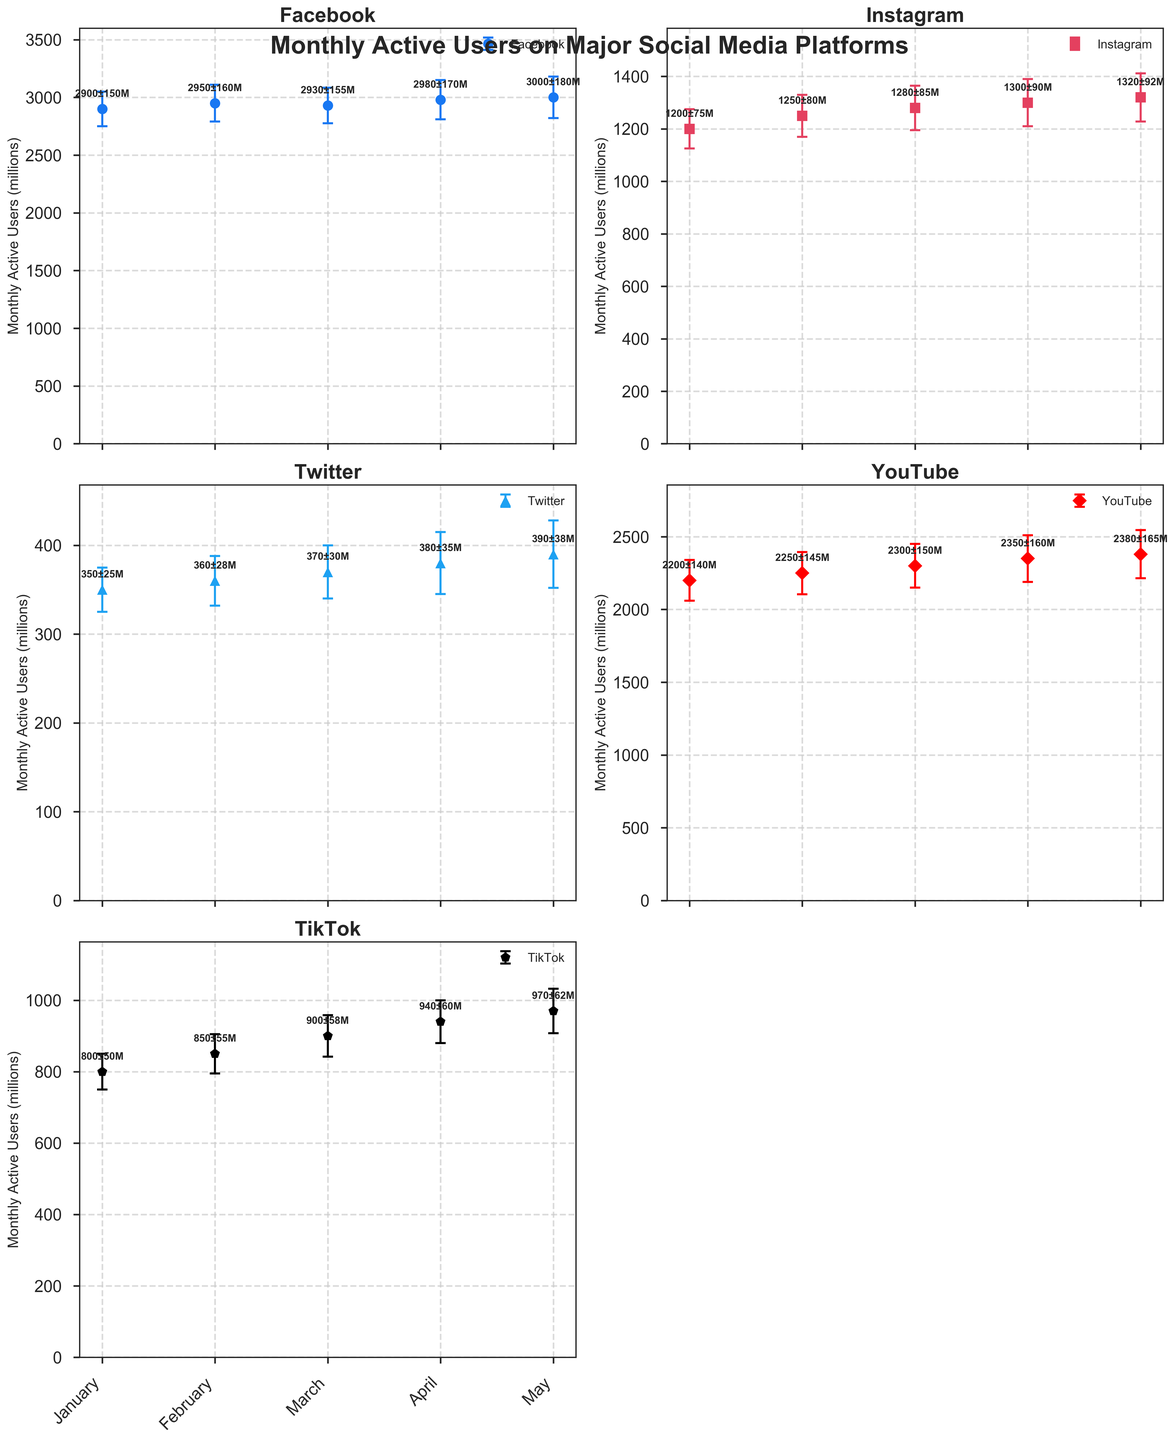What is the title of the figure? The title is displayed at the top of the figure and reads, "Monthly Active Users on Major Social Media Platforms".
Answer: Monthly Active Users on Major Social Media Platforms How many platforms are displayed in the figure? The figure shows five major social media platforms.
Answer: 5 Which platform has the smallest error margin in January? By examining the error bars, Twitter has the smallest error margin of 25 million in January.
Answer: Twitter What is the average Monthly Active Users (MAU) for Instagram across the months shown? The MAUs for Instagram are January: 1200, February: 1250, March: 1280, April: 1300, and May: 1320. Their average is (1200 + 1250 + 1280 + 1300 + 1320) / 5 = 6350 / 5 = 1270.
Answer: 1270 Which platform shows the largest increase in Monthly Active Users from January to May? The Monthly Active Users (MAU) increase for each platform is computed from January to May data. TikTok shows an increase from 800 to 970, an increase of 170 million, the largest among all platforms.
Answer: TikTok Which month shows the highest Monthly Active Users for Facebook? The highest MAU for Facebook is in May at 3000 million users.
Answer: May Compare the Monthly Active Users for YouTube in February and March. Which month has a higher MAU and by how much? YouTube's MAU for February is 2250 and for March is 2300. March has a higher MAU with a difference of 2300 - 2250 = 50 million.
Answer: March, by 50 million What is the range of error margins for TikTok across all months? TikTok's error margins across the months are January: 50, February: 55, March: 58, April: 60, and May: 62. The range is from 50 to 62 million.
Answer: 50 to 62 million Which platform had the highest Monthly Active Users in May, and what is that value? By comparing the MAU values for May, Facebook had the highest MAU with 3000 million users.
Answer: Facebook, 3000 million For which platform does the error margin seem to increase steadily over the months? By examining the error bars, the error margin for Facebook seems to increase steadily from January (150) to May (180).
Answer: Facebook 